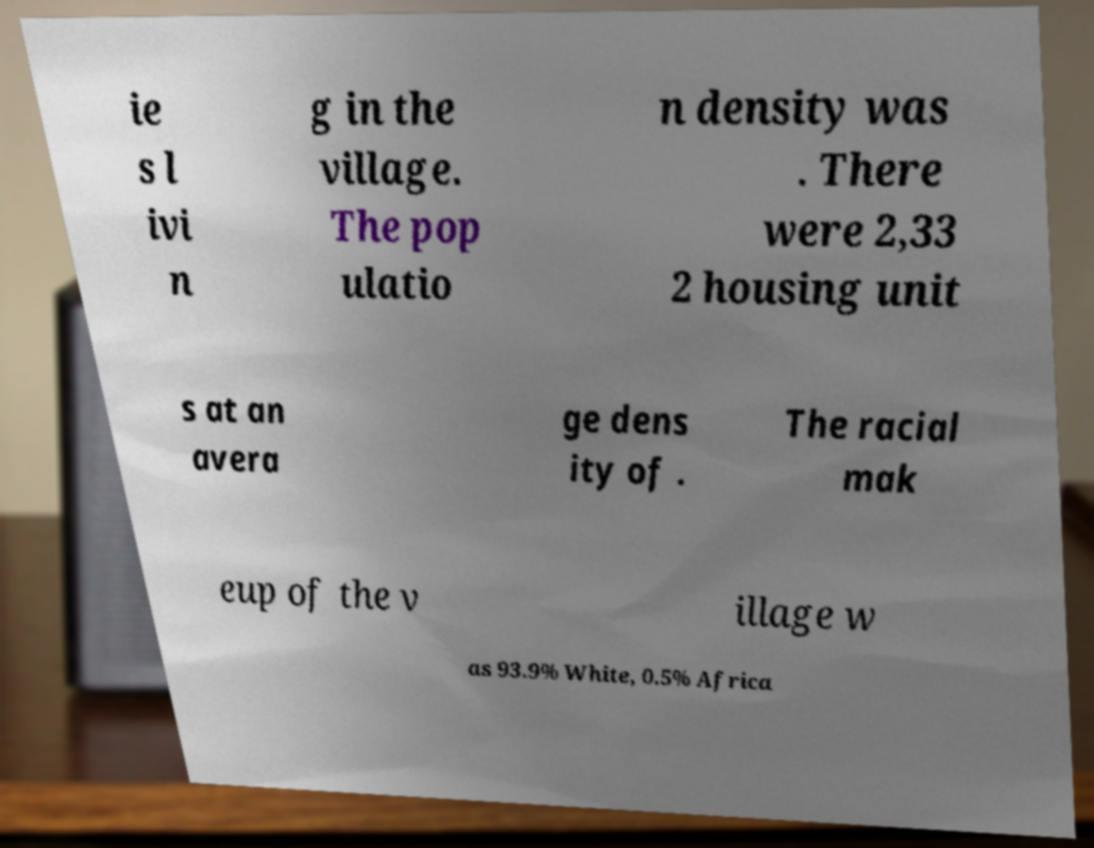Can you accurately transcribe the text from the provided image for me? ie s l ivi n g in the village. The pop ulatio n density was . There were 2,33 2 housing unit s at an avera ge dens ity of . The racial mak eup of the v illage w as 93.9% White, 0.5% Africa 